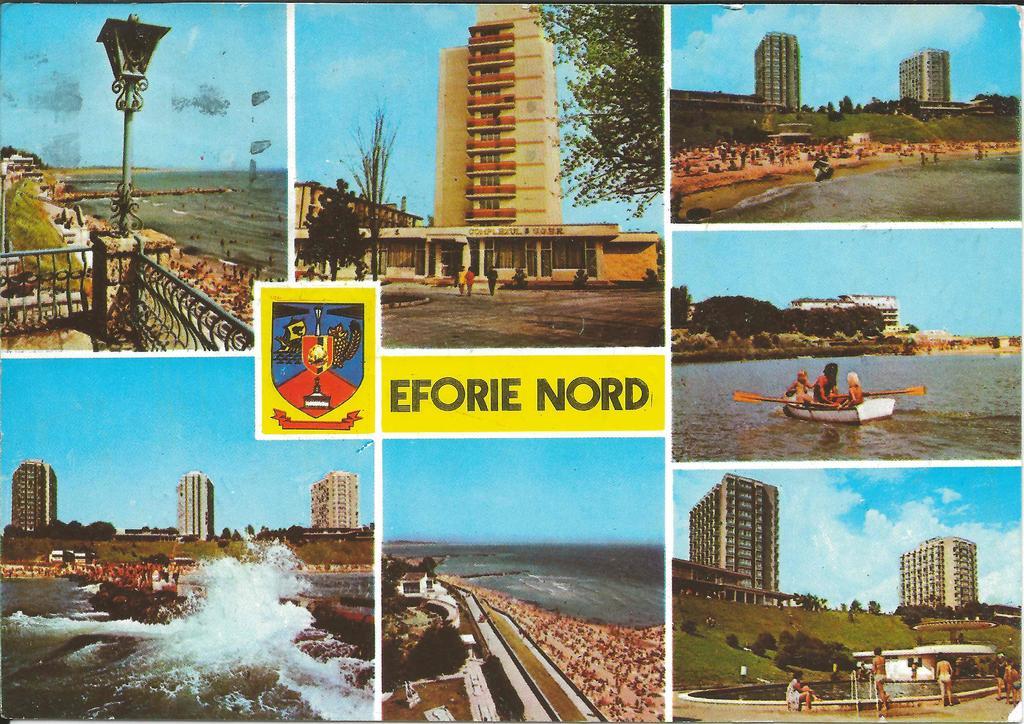Describe this image in one or two sentences. This image is a collage image. Here we have seven pictures in one image. In this images we have buildings and some rivers and there is a road on the bottom of this image and there is a fountain on the bottom right corner of this image, and there is a text with some logo in middle of this image. 